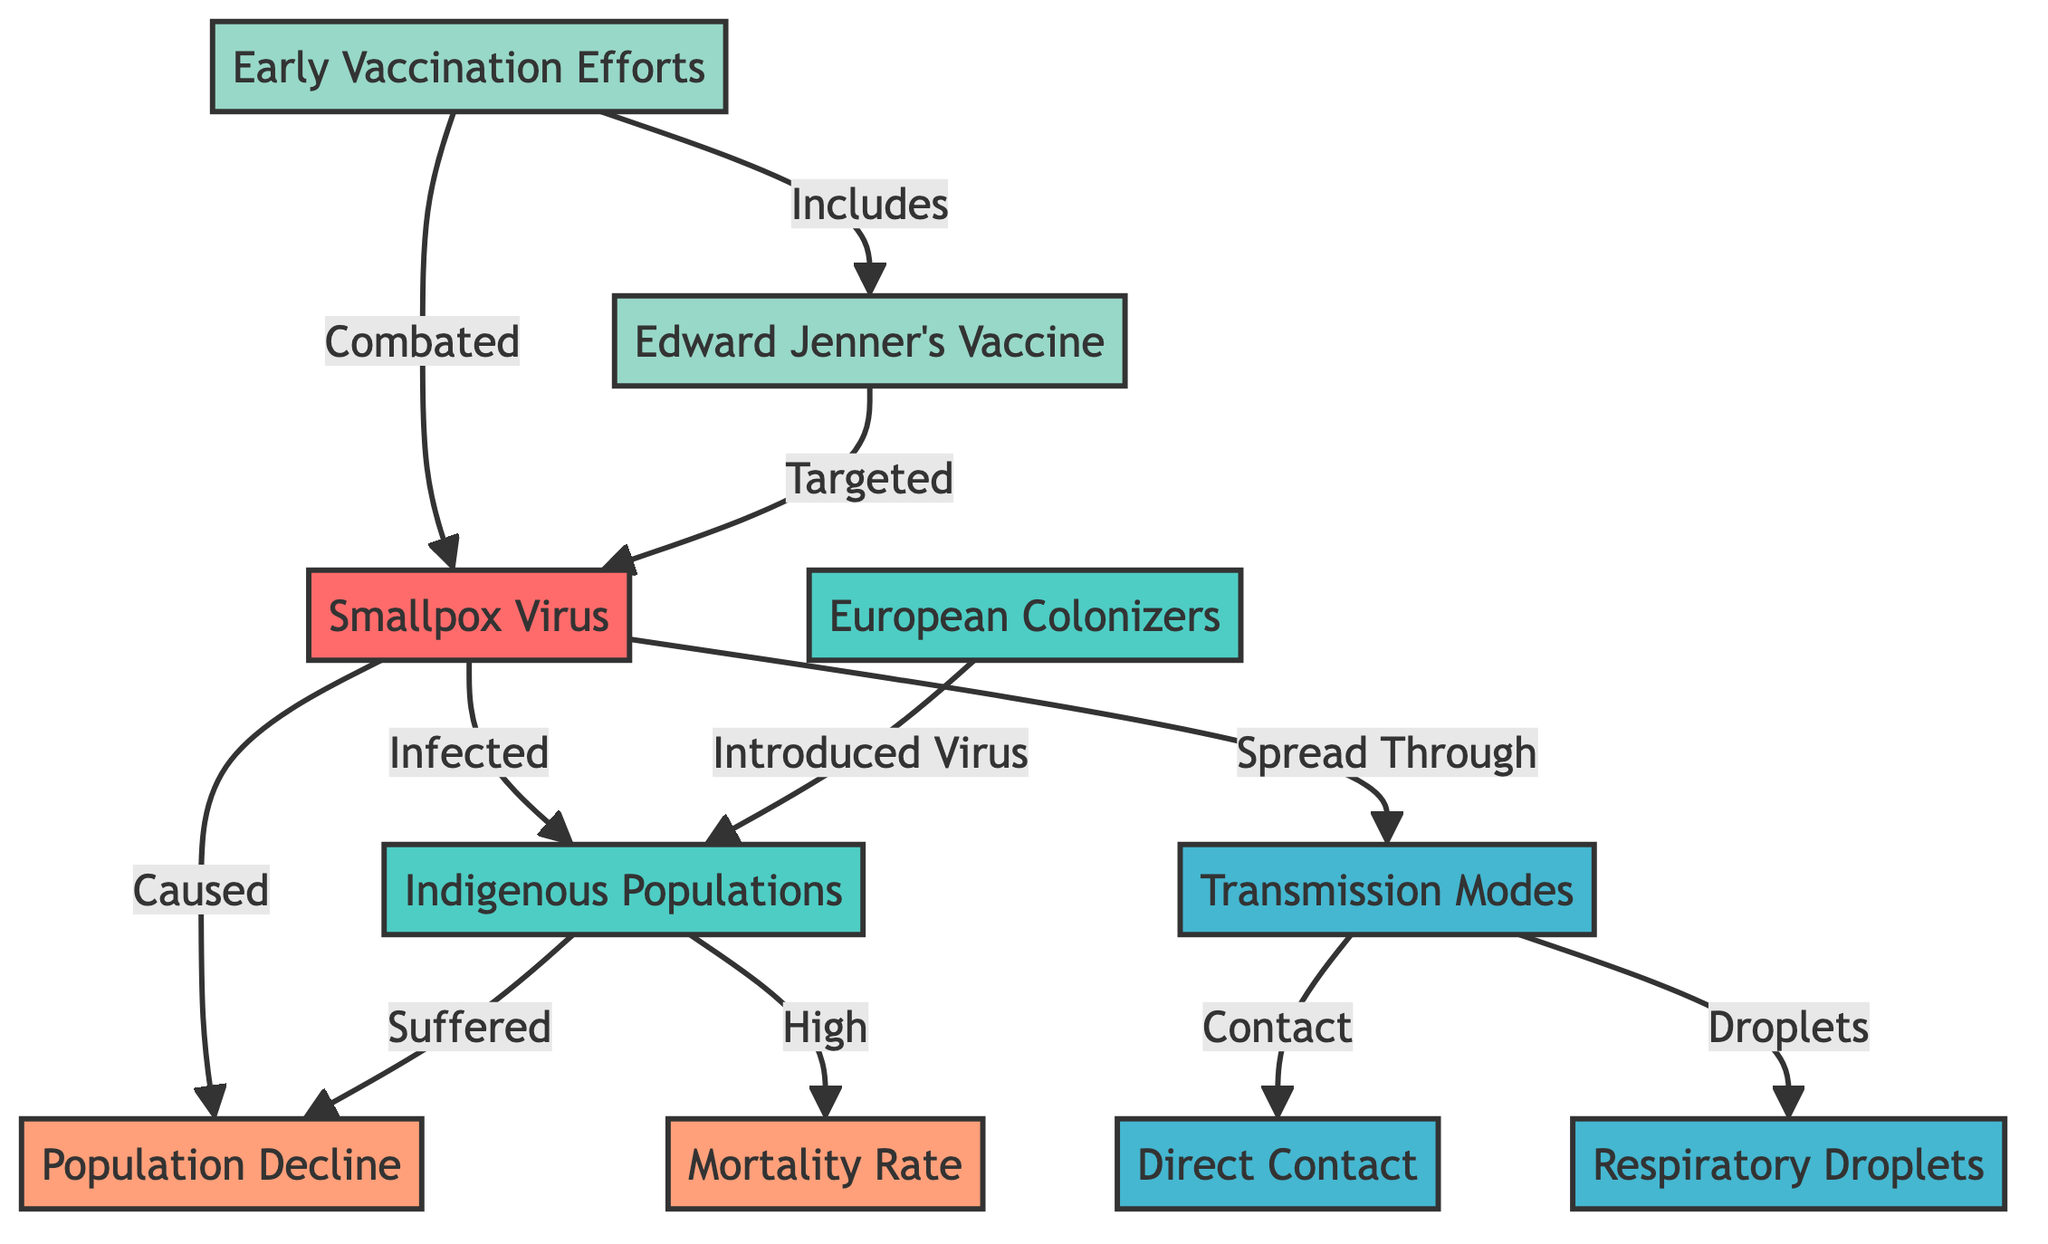What are the modes of transmission for smallpox illustrated in the diagram? The diagram shows two main modes of transmission for smallpox: Direct Contact and Respiratory Droplets. These can be found branching from the Transmission Modes node.
Answer: Direct Contact, Respiratory Droplets How many populations are affected by smallpox in the diagram? The diagram highlights two populations affected by smallpox: Indigenous Populations and European Colonizers. Since there are two distinct population nodes visible in the diagram, the answer is two.
Answer: 2 What is the relationship between smallpox and population decline? The diagram illustrates that the Smallpox Virus caused the Population Decline, indicating a direct causal relationship, where smallpox contributed significantly to the decline in Indigenous populations.
Answer: Caused What early vaccination effort is described in the diagram? The diagram depicts Edward Jenner's Vaccine as a significant early vaccination effort aimed at combating the Smallpox Virus, indicated by the connections from Early Vaccination Efforts to Smallpox Virus.
Answer: Edward Jenner's Vaccine Which population suffered a high mortality rate due to smallpox according to the diagram? The Indigenous Populations node is connected to the Mortality Rate node with the indication that they suffered a high mortality rate as a result of smallpox infection. This suggests the Indigenous populations faced the most significant impact.
Answer: Indigenous Populations 